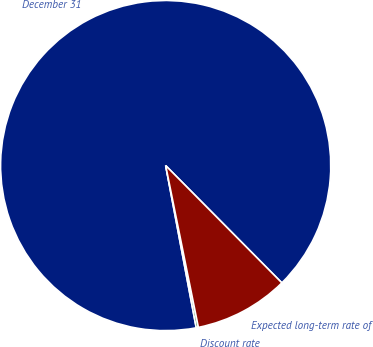<chart> <loc_0><loc_0><loc_500><loc_500><pie_chart><fcel>December 31<fcel>Discount rate<fcel>Expected long-term rate of<nl><fcel>90.54%<fcel>0.21%<fcel>9.25%<nl></chart> 